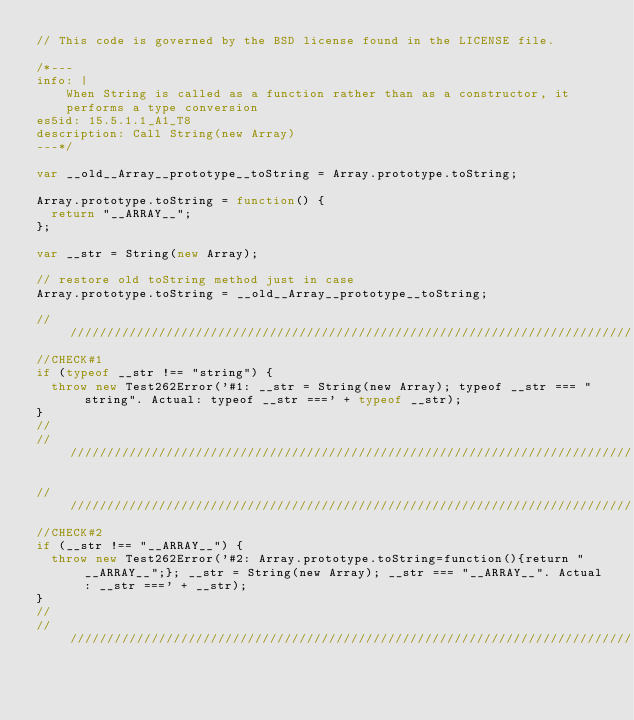Convert code to text. <code><loc_0><loc_0><loc_500><loc_500><_JavaScript_>// This code is governed by the BSD license found in the LICENSE file.

/*---
info: |
    When String is called as a function rather than as a constructor, it
    performs a type conversion
es5id: 15.5.1.1_A1_T8
description: Call String(new Array)
---*/

var __old__Array__prototype__toString = Array.prototype.toString;

Array.prototype.toString = function() {
  return "__ARRAY__";
};

var __str = String(new Array);

// restore old toString method just in case
Array.prototype.toString = __old__Array__prototype__toString;

//////////////////////////////////////////////////////////////////////////////
//CHECK#1
if (typeof __str !== "string") {
  throw new Test262Error('#1: __str = String(new Array); typeof __str === "string". Actual: typeof __str ===' + typeof __str);
}
//
//////////////////////////////////////////////////////////////////////////////

//////////////////////////////////////////////////////////////////////////////
//CHECK#2
if (__str !== "__ARRAY__") {
  throw new Test262Error('#2: Array.prototype.toString=function(){return "__ARRAY__";}; __str = String(new Array); __str === "__ARRAY__". Actual: __str ===' + __str);
}
//
//////////////////////////////////////////////////////////////////////////////
</code> 